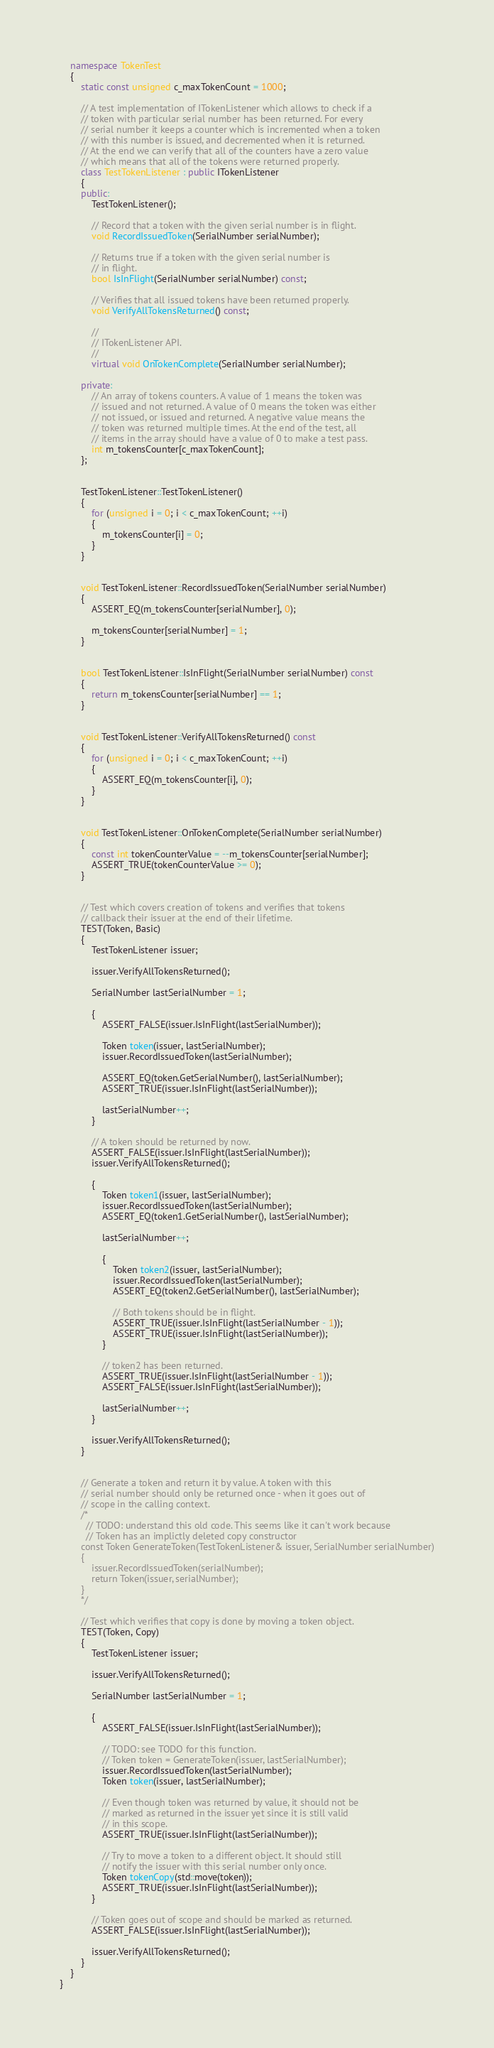Convert code to text. <code><loc_0><loc_0><loc_500><loc_500><_C++_>    namespace TokenTest
    {
        static const unsigned c_maxTokenCount = 1000;

        // A test implementation of ITokenListener which allows to check if a
        // token with particular serial number has been returned. For every
        // serial number it keeps a counter which is incremented when a token
        // with this number is issued, and decremented when it is returned.
        // At the end we can verify that all of the counters have a zero value
        // which means that all of the tokens were returned properly.
        class TestTokenListener : public ITokenListener
        {
        public:
            TestTokenListener();

            // Record that a token with the given serial number is in flight.
            void RecordIssuedToken(SerialNumber serialNumber);

            // Returns true if a token with the given serial number is
            // in flight.
            bool IsInFlight(SerialNumber serialNumber) const;

            // Verifies that all issued tokens have been returned properly.
            void VerifyAllTokensReturned() const;

            //
            // ITokenListener API.
            //
            virtual void OnTokenComplete(SerialNumber serialNumber);

        private:
            // An array of tokens counters. A value of 1 means the token was
            // issued and not returned. A value of 0 means the token was either
            // not issued, or issued and returned. A negative value means the
            // token was returned multiple times. At the end of the test, all
            // items in the array should have a value of 0 to make a test pass.
            int m_tokensCounter[c_maxTokenCount];
        };


        TestTokenListener::TestTokenListener()
        {
            for (unsigned i = 0; i < c_maxTokenCount; ++i)
            {
                m_tokensCounter[i] = 0;
            }
        }


        void TestTokenListener::RecordIssuedToken(SerialNumber serialNumber)
        {
            ASSERT_EQ(m_tokensCounter[serialNumber], 0);

            m_tokensCounter[serialNumber] = 1;
        }


        bool TestTokenListener::IsInFlight(SerialNumber serialNumber) const
        {
            return m_tokensCounter[serialNumber] == 1;
        }


        void TestTokenListener::VerifyAllTokensReturned() const
        {
            for (unsigned i = 0; i < c_maxTokenCount; ++i)
            {
                ASSERT_EQ(m_tokensCounter[i], 0);
            }
        }


        void TestTokenListener::OnTokenComplete(SerialNumber serialNumber)
        {
            const int tokenCounterValue = --m_tokensCounter[serialNumber];
            ASSERT_TRUE(tokenCounterValue >= 0);
        }


        // Test which covers creation of tokens and verifies that tokens
        // callback their issuer at the end of their lifetime.
        TEST(Token, Basic)
        {
            TestTokenListener issuer;

            issuer.VerifyAllTokensReturned();

            SerialNumber lastSerialNumber = 1;

            {
                ASSERT_FALSE(issuer.IsInFlight(lastSerialNumber));

                Token token(issuer, lastSerialNumber);
                issuer.RecordIssuedToken(lastSerialNumber);

                ASSERT_EQ(token.GetSerialNumber(), lastSerialNumber);
                ASSERT_TRUE(issuer.IsInFlight(lastSerialNumber));

                lastSerialNumber++;
            }

            // A token should be returned by now.
            ASSERT_FALSE(issuer.IsInFlight(lastSerialNumber));
            issuer.VerifyAllTokensReturned();

            {
                Token token1(issuer, lastSerialNumber);
                issuer.RecordIssuedToken(lastSerialNumber);
                ASSERT_EQ(token1.GetSerialNumber(), lastSerialNumber);

                lastSerialNumber++;

                {
                    Token token2(issuer, lastSerialNumber);
                    issuer.RecordIssuedToken(lastSerialNumber);
                    ASSERT_EQ(token2.GetSerialNumber(), lastSerialNumber);

                    // Both tokens should be in flight.
                    ASSERT_TRUE(issuer.IsInFlight(lastSerialNumber - 1));
                    ASSERT_TRUE(issuer.IsInFlight(lastSerialNumber));
                }

                // token2 has been returned.
                ASSERT_TRUE(issuer.IsInFlight(lastSerialNumber - 1));
                ASSERT_FALSE(issuer.IsInFlight(lastSerialNumber));

                lastSerialNumber++;
            }

            issuer.VerifyAllTokensReturned();
        }


        // Generate a token and return it by value. A token with this
        // serial number should only be returned once - when it goes out of
        // scope in the calling context.
        /*
          // TODO: understand this old code. This seems like it can't work because
          // Token has an implictly deleted copy constructor
        const Token GenerateToken(TestTokenListener& issuer, SerialNumber serialNumber)
        {
            issuer.RecordIssuedToken(serialNumber);
            return Token(issuer, serialNumber);
        }
        */

        // Test which verifies that copy is done by moving a token object.
        TEST(Token, Copy)
        {
            TestTokenListener issuer;

            issuer.VerifyAllTokensReturned();

            SerialNumber lastSerialNumber = 1;

            {
                ASSERT_FALSE(issuer.IsInFlight(lastSerialNumber));

                // TODO: see TODO for this function.
                // Token token = GenerateToken(issuer, lastSerialNumber);
                issuer.RecordIssuedToken(lastSerialNumber);
                Token token(issuer, lastSerialNumber);

                // Even though token was returned by value, it should not be
                // marked as returned in the issuer yet since it is still valid
                // in this scope.
                ASSERT_TRUE(issuer.IsInFlight(lastSerialNumber));

                // Try to move a token to a different object. It should still
                // notify the issuer with this serial number only once.
                Token tokenCopy(std::move(token));
                ASSERT_TRUE(issuer.IsInFlight(lastSerialNumber));
            }

            // Token goes out of scope and should be marked as returned.
            ASSERT_FALSE(issuer.IsInFlight(lastSerialNumber));

            issuer.VerifyAllTokensReturned();
        }
    }
}
</code> 